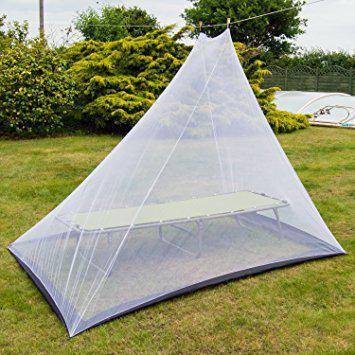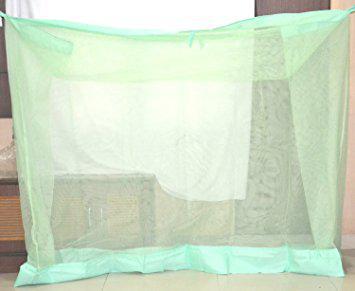The first image is the image on the left, the second image is the image on the right. For the images displayed, is the sentence "the mosquito net on the right is round" factually correct? Answer yes or no. No. 